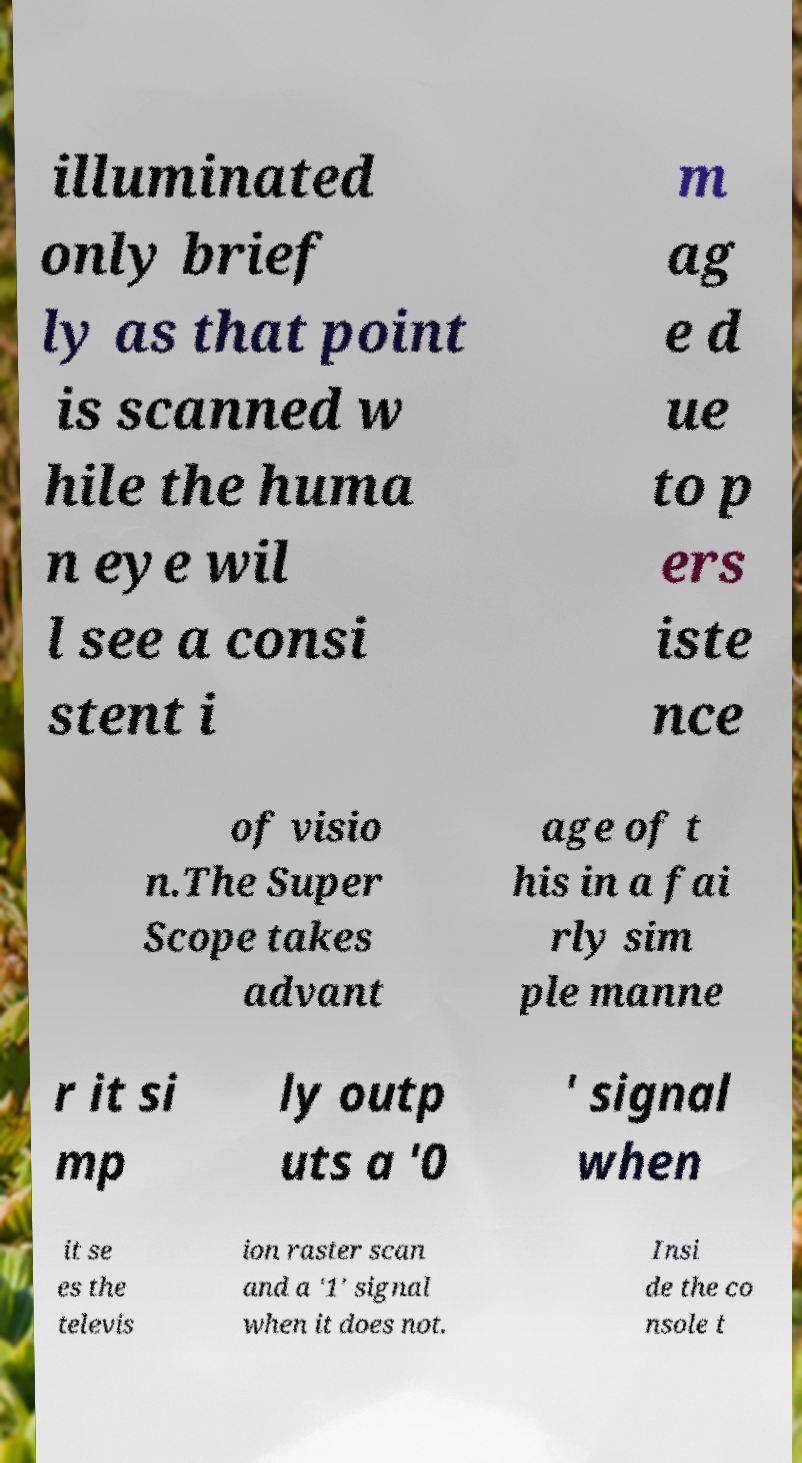There's text embedded in this image that I need extracted. Can you transcribe it verbatim? illuminated only brief ly as that point is scanned w hile the huma n eye wil l see a consi stent i m ag e d ue to p ers iste nce of visio n.The Super Scope takes advant age of t his in a fai rly sim ple manne r it si mp ly outp uts a '0 ' signal when it se es the televis ion raster scan and a '1' signal when it does not. Insi de the co nsole t 